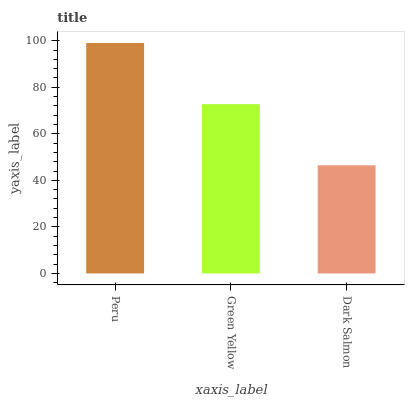Is Dark Salmon the minimum?
Answer yes or no. Yes. Is Peru the maximum?
Answer yes or no. Yes. Is Green Yellow the minimum?
Answer yes or no. No. Is Green Yellow the maximum?
Answer yes or no. No. Is Peru greater than Green Yellow?
Answer yes or no. Yes. Is Green Yellow less than Peru?
Answer yes or no. Yes. Is Green Yellow greater than Peru?
Answer yes or no. No. Is Peru less than Green Yellow?
Answer yes or no. No. Is Green Yellow the high median?
Answer yes or no. Yes. Is Green Yellow the low median?
Answer yes or no. Yes. Is Peru the high median?
Answer yes or no. No. Is Peru the low median?
Answer yes or no. No. 